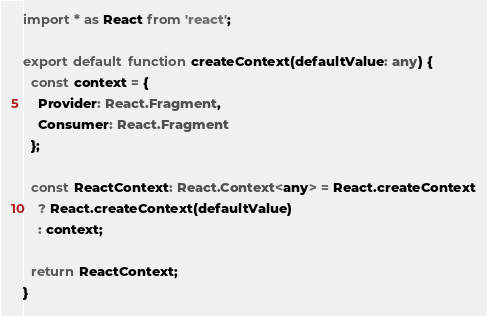<code> <loc_0><loc_0><loc_500><loc_500><_TypeScript_>import * as React from 'react';

export default function createContext(defaultValue: any) {
  const context = {
    Provider: React.Fragment,
    Consumer: React.Fragment
  };

  const ReactContext: React.Context<any> = React.createContext
    ? React.createContext(defaultValue)
    : context;

  return ReactContext;
}
</code> 